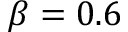Convert formula to latex. <formula><loc_0><loc_0><loc_500><loc_500>\beta = 0 . 6</formula> 